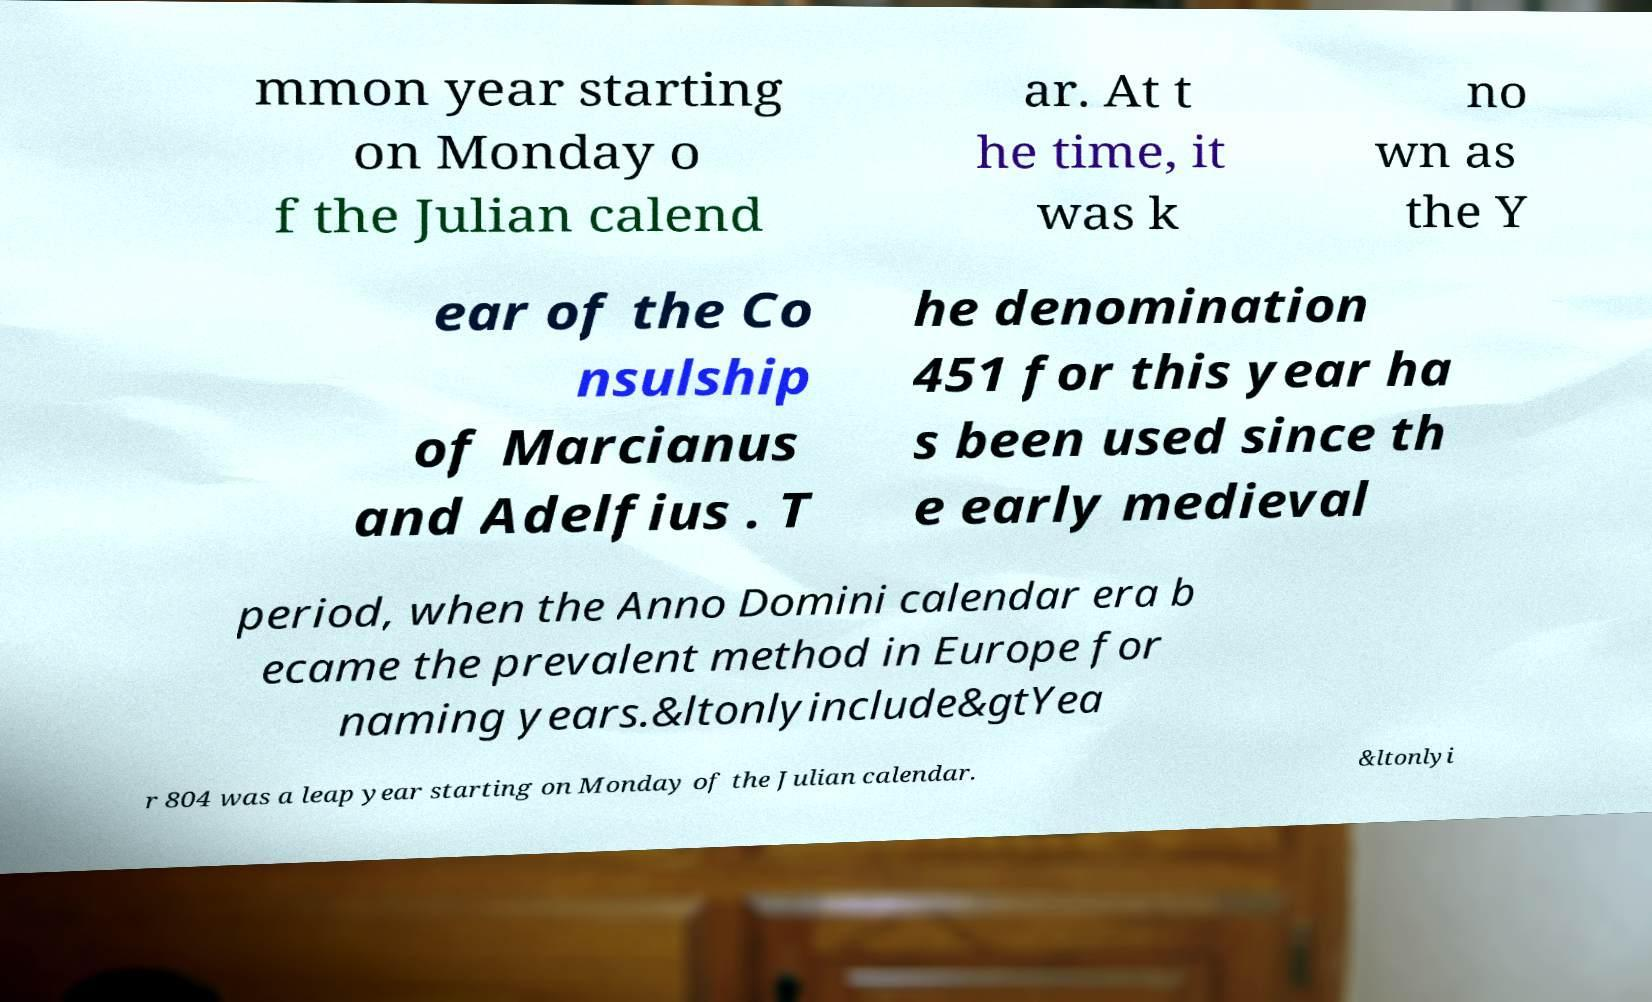Please identify and transcribe the text found in this image. mmon year starting on Monday o f the Julian calend ar. At t he time, it was k no wn as the Y ear of the Co nsulship of Marcianus and Adelfius . T he denomination 451 for this year ha s been used since th e early medieval period, when the Anno Domini calendar era b ecame the prevalent method in Europe for naming years.&ltonlyinclude&gtYea r 804 was a leap year starting on Monday of the Julian calendar. &ltonlyi 